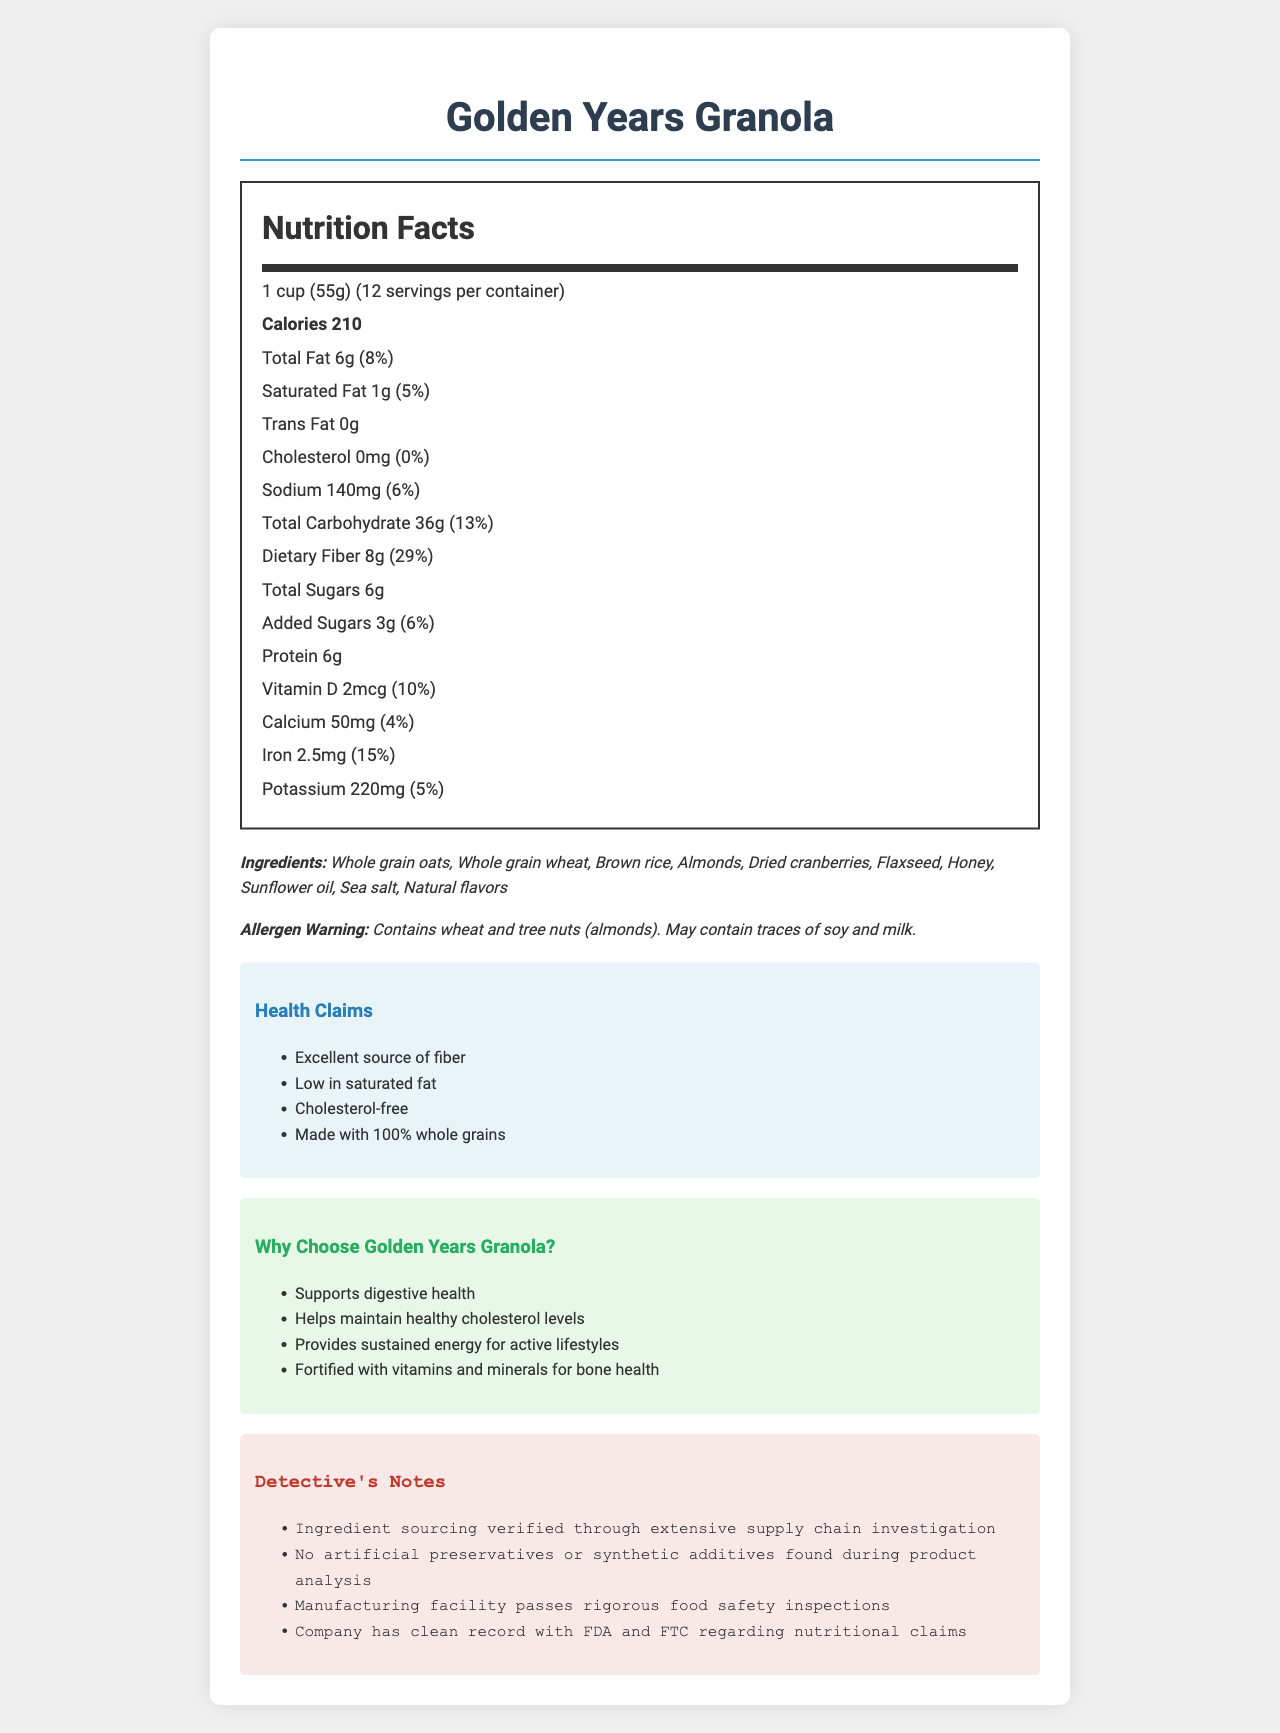what is the serving size of Golden Years Granola? The serving size is listed as "1 cup (55g)" near the top of the Nutrition Facts.
Answer: 1 cup (55g) how many servings are there per container? The servings per container are listed just next to the serving size, indicating there are 12 servings in each container.
Answer: 12 how much dietary fiber is in each serving? The amount of dietary fiber per serving is stated as "8g" under the Total Carbohydrate section.
Answer: 8g what percentage of the daily value of dietary fiber does one serving provide? The percentage daily value of dietary fiber is shown as "29%" next to the dietary fiber amount.
Answer: 29% what are the main ingredients in Golden Years Granola? The ingredients list includes whole grain oats, whole grain wheat, brown rice, almonds, dried cranberries, flaxseed, honey, sunflower oil, sea salt, and natural flavors.
Answer: Whole grain oats, Whole grain wheat, Brown rice, Almonds, Dried cranberries, Flaxseed, Honey, Sunflower oil, Sea salt, Natural flavors how much protein is there per serving? The protein content per serving is 6g, as listed in the Nutrition Facts.
Answer: 6g what is the sodium content per serving? The sodium content per serving is listed as "140mg" in the Nutrition Facts.
Answer: 140mg are there any allergens in Golden Years Granola? The allergen warning states that the product contains wheat and tree nuts (almonds) and may contain traces of soy and milk.
Answer: Yes how many calories are there per serving? The calorie count per serving is listed as "210" in the Nutrition Facts.
Answer: 210 What dietary benefit is highlighted by the health claims? A. Low Calories B. Excellent source of fiber C. Low Sugar D. High Protein The health claims mention "Excellent source of fiber" which highlights the high fiber content.
Answer: B Which of the following is not listed as an ingredient in Golden Years Granola? 
I. Honey II. Almonds III. Chocolate IV. Flaxseed Chocolate is not listed among the ingredients, unlike honey, almonds, and flaxseed.
Answer: III is Golden Years Granola cholesterol-free? The cholesterol content is listed as "0mg" (0%), indicating it is cholesterol-free.
Answer: Yes Summarize the document The document detailedly describes Golden Years Granola, including its nutrition content, ingredients, health benefits, and allergen information. It also ensures the product's quality and reliability through detective's notes.
Answer: The document provides detailed information on Golden Years Granola, a fiber-rich, whole grain cereal aimed at health-conscious seniors and active retirees. It includes nutrition facts, ingredient list, health claims, and marketing points. The product is highlighted for its high fiber content, benefits for heart and digestive health, presence of whole grains, and absence of cholesterol. It also includes allergen warnings and detective's notes ensuring quality and compliance. What steps has the company taken to ensure product safety and compliance? The detective's notes outline steps like verified ingredient sourcing, absence of artificial preservatives, safety inspections, and a clean regulatory record to ensure product safety and compliance.
Answer: Verified ingredient sourcing, no artificial preservatives or synthetic additives, passed rigorous food safety inspections, clean record with FDA and FTC Can you provide the manufacturing cost of Golden Years Granola? The document does not provide any information about the manufacturing cost, focusing solely on nutritional and marketing aspects.
Answer: Cannot be determined What health claims are made about Golden Years Granola? The health claims section lists "Excellent source of fiber", "Low in saturated fat", "Cholesterol-free", and "Made with 100% whole grains".
Answer: Excellent source of fiber, Low in saturated fat, Cholesterol-free, Made with 100% whole grains 